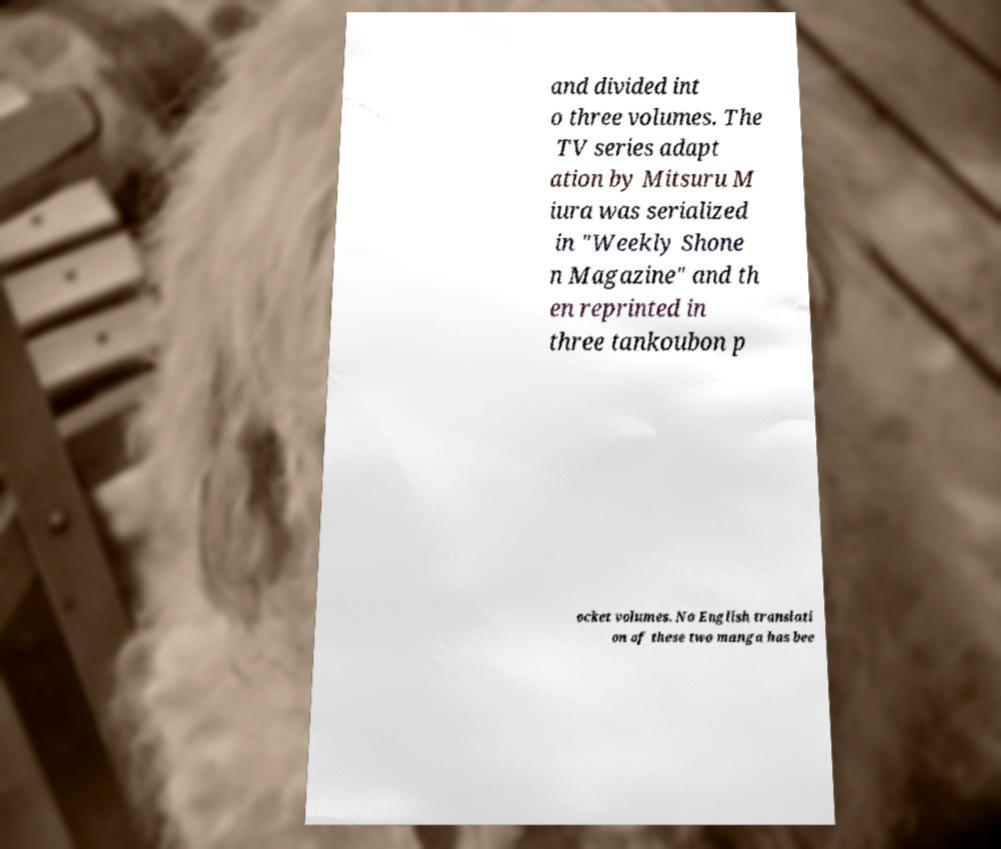Please identify and transcribe the text found in this image. and divided int o three volumes. The TV series adapt ation by Mitsuru M iura was serialized in "Weekly Shone n Magazine" and th en reprinted in three tankoubon p ocket volumes. No English translati on of these two manga has bee 